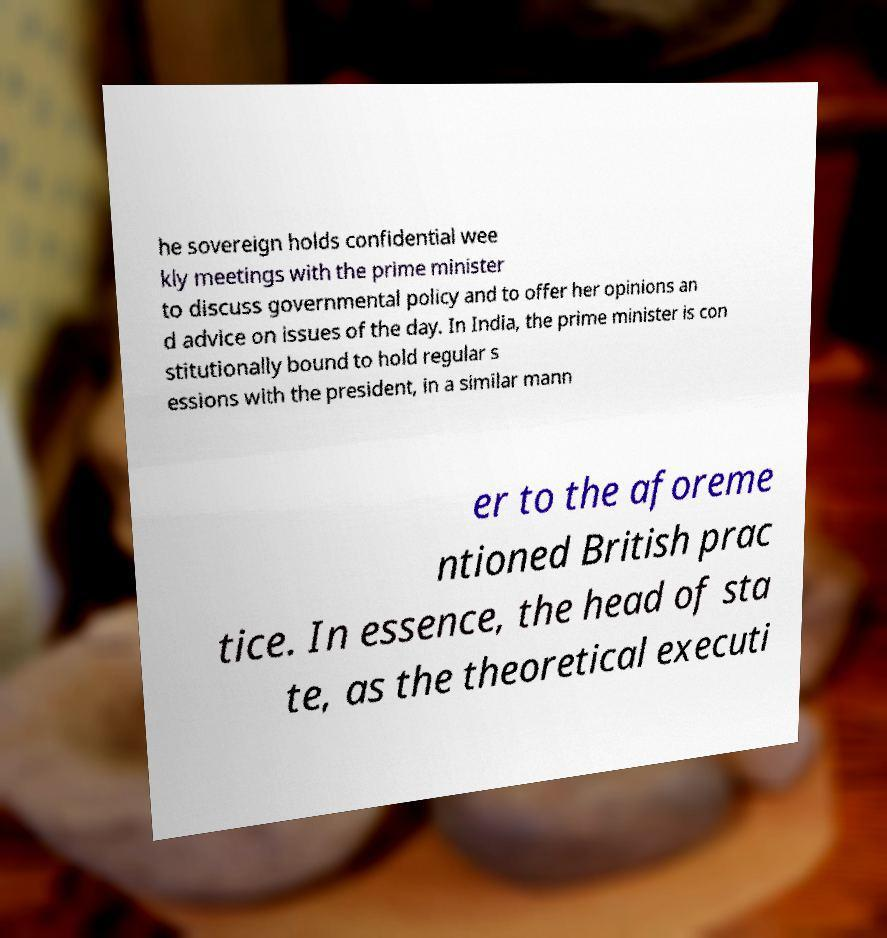Please identify and transcribe the text found in this image. he sovereign holds confidential wee kly meetings with the prime minister to discuss governmental policy and to offer her opinions an d advice on issues of the day. In India, the prime minister is con stitutionally bound to hold regular s essions with the president, in a similar mann er to the aforeme ntioned British prac tice. In essence, the head of sta te, as the theoretical executi 